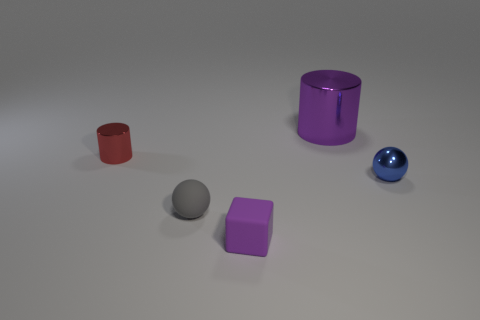Add 2 tiny balls. How many objects exist? 7 Subtract all balls. How many objects are left? 3 Subtract all tiny red shiny things. Subtract all tiny red metallic objects. How many objects are left? 3 Add 3 tiny red cylinders. How many tiny red cylinders are left? 4 Add 5 purple matte cubes. How many purple matte cubes exist? 6 Subtract 1 purple blocks. How many objects are left? 4 